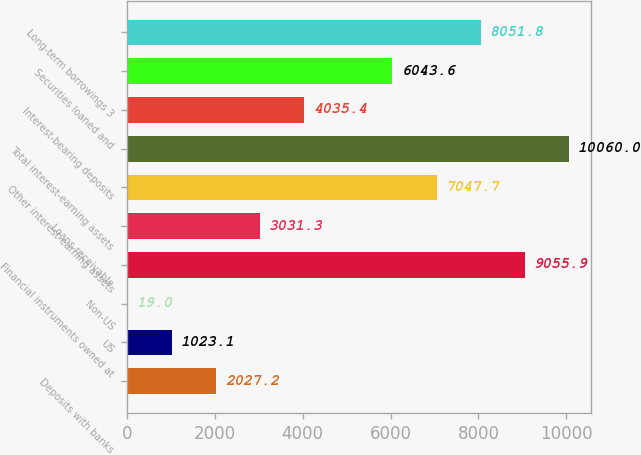Convert chart to OTSL. <chart><loc_0><loc_0><loc_500><loc_500><bar_chart><fcel>Deposits with banks<fcel>US<fcel>Non-US<fcel>Financial instruments owned at<fcel>Loans receivable<fcel>Other interest-earning assets<fcel>Total interest-earning assets<fcel>Interest-bearing deposits<fcel>Securities loaned and<fcel>Long-term borrowings 3<nl><fcel>2027.2<fcel>1023.1<fcel>19<fcel>9055.9<fcel>3031.3<fcel>7047.7<fcel>10060<fcel>4035.4<fcel>6043.6<fcel>8051.8<nl></chart> 